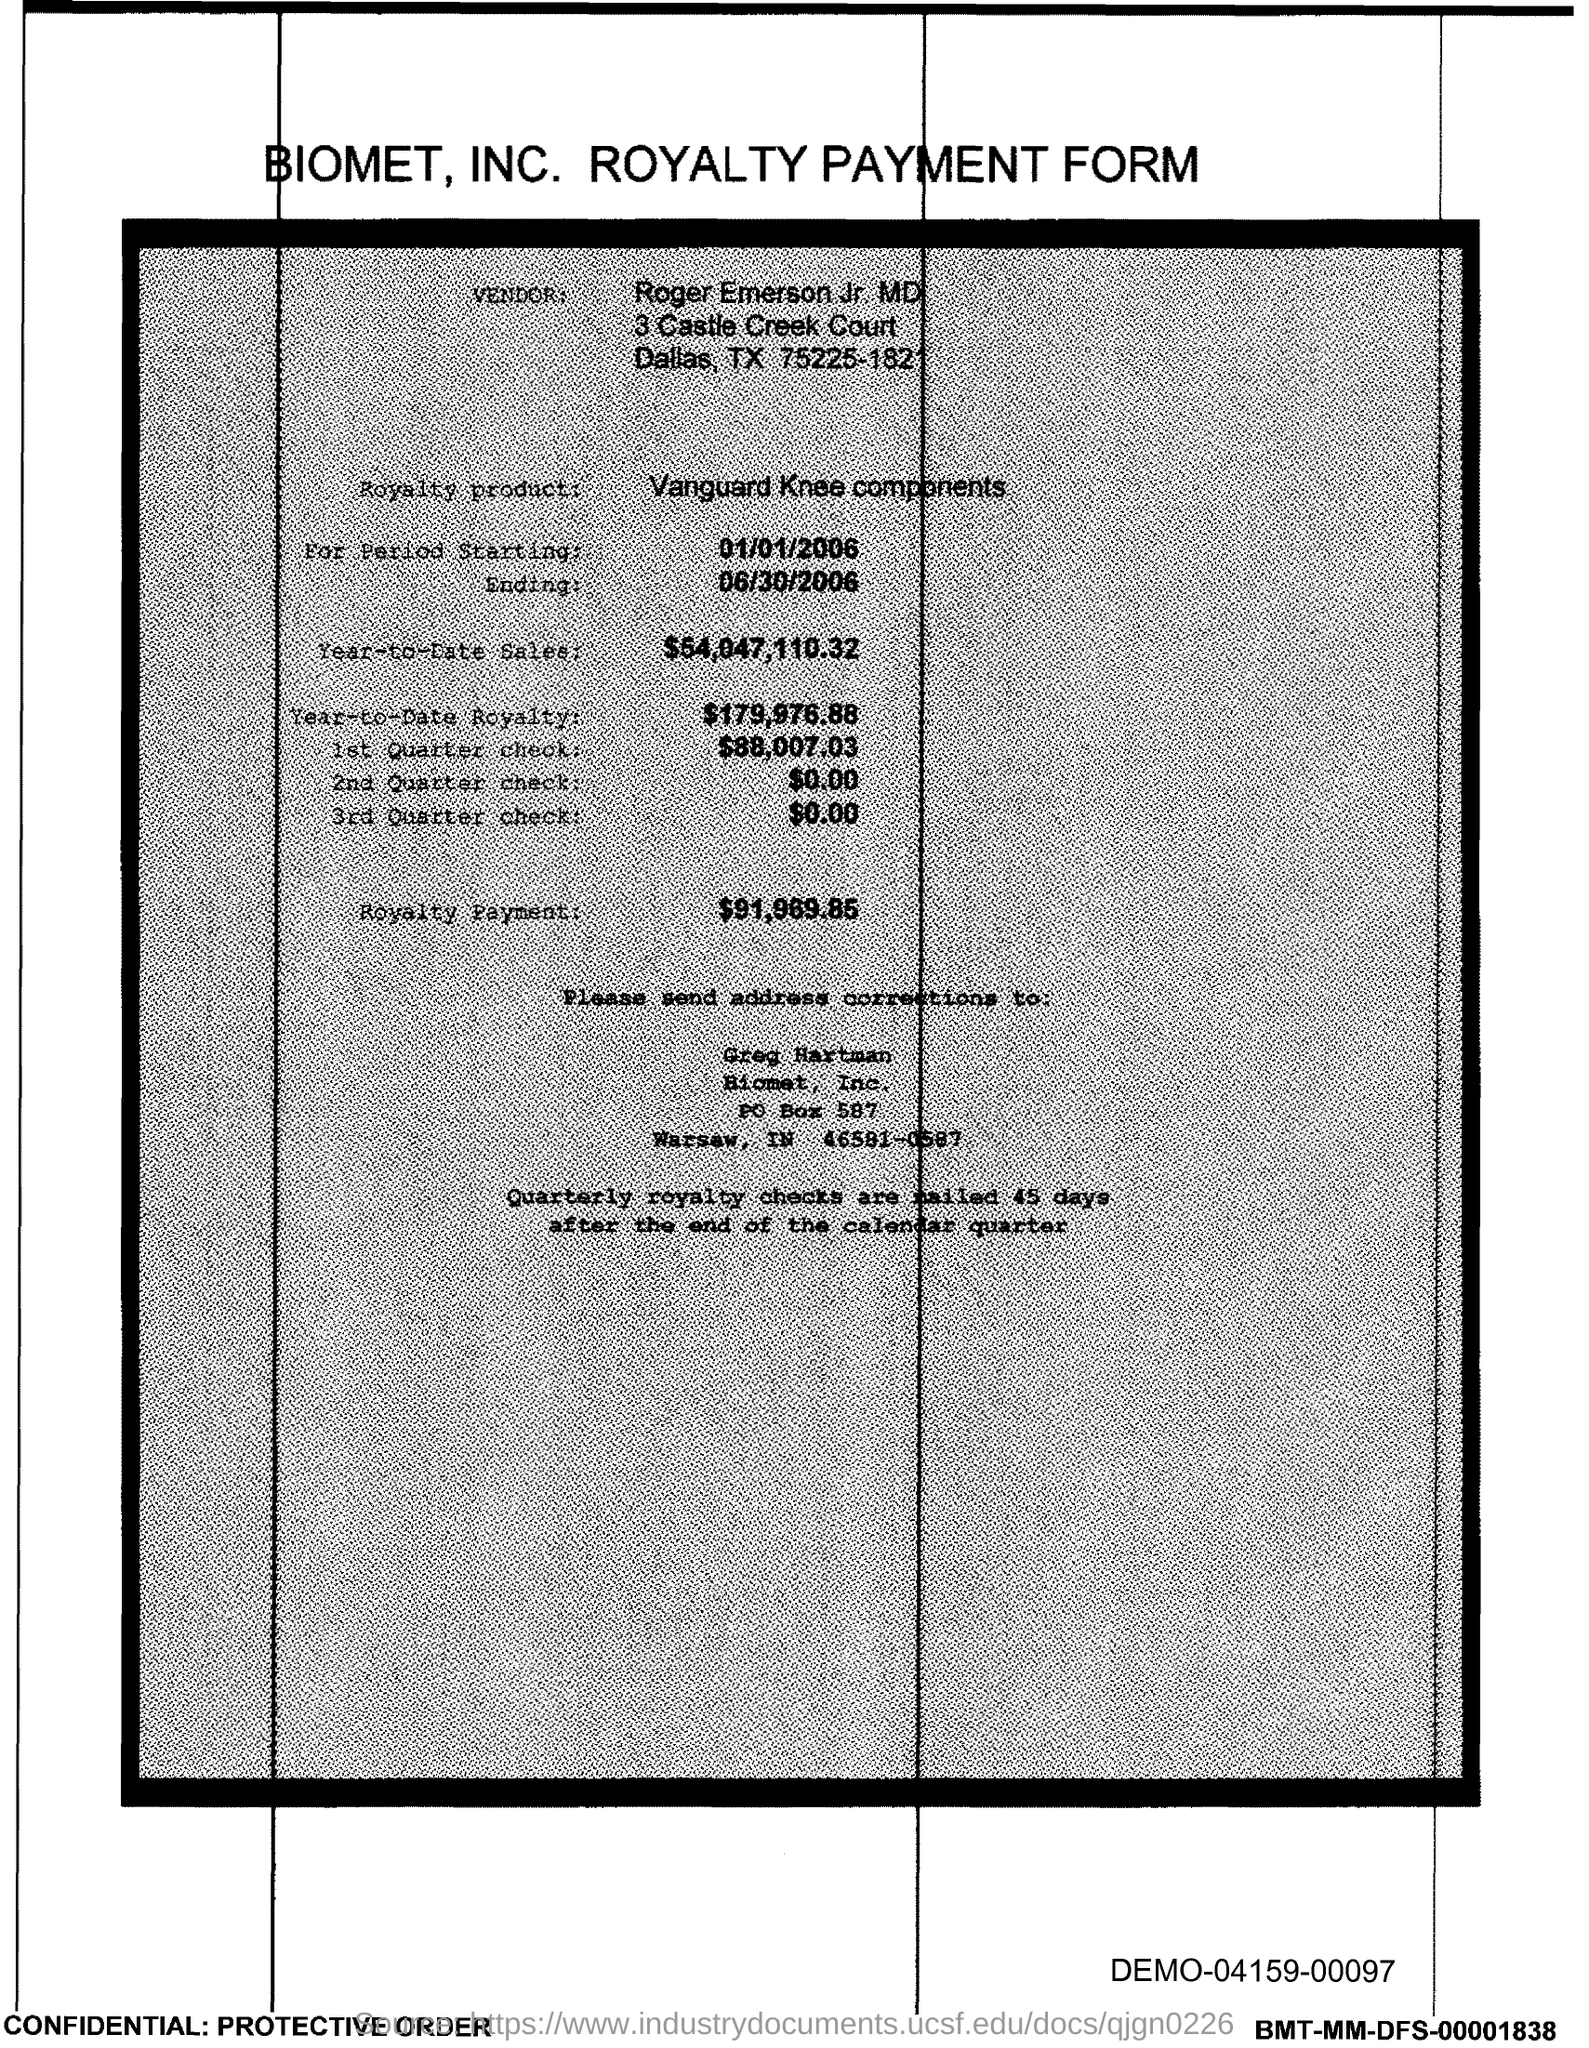Which company's royalty payment form is this?
Give a very brief answer. Biomet, Inc. What is the vendor name given in the form?
Your answer should be very brief. Roger Emerson Jr. MD. What is the royalty product given in the form?
Provide a short and direct response. Vanguard Knee components. What is the Year-to-Date royalty of the product?
Provide a short and direct response. $179,976.88. What is the amount of 3rd Quarter check given in the form?
Provide a succinct answer. $0.00. What is the amount of 2nd Quarter check mentioned in the form?
Provide a short and direct response. $0.00. What is the amount of 1st quarter check mentioned in the form?
Give a very brief answer. $88,007.03. What is the royalty payment of the product mentioned in the form?
Offer a very short reply. $91,969.85. 